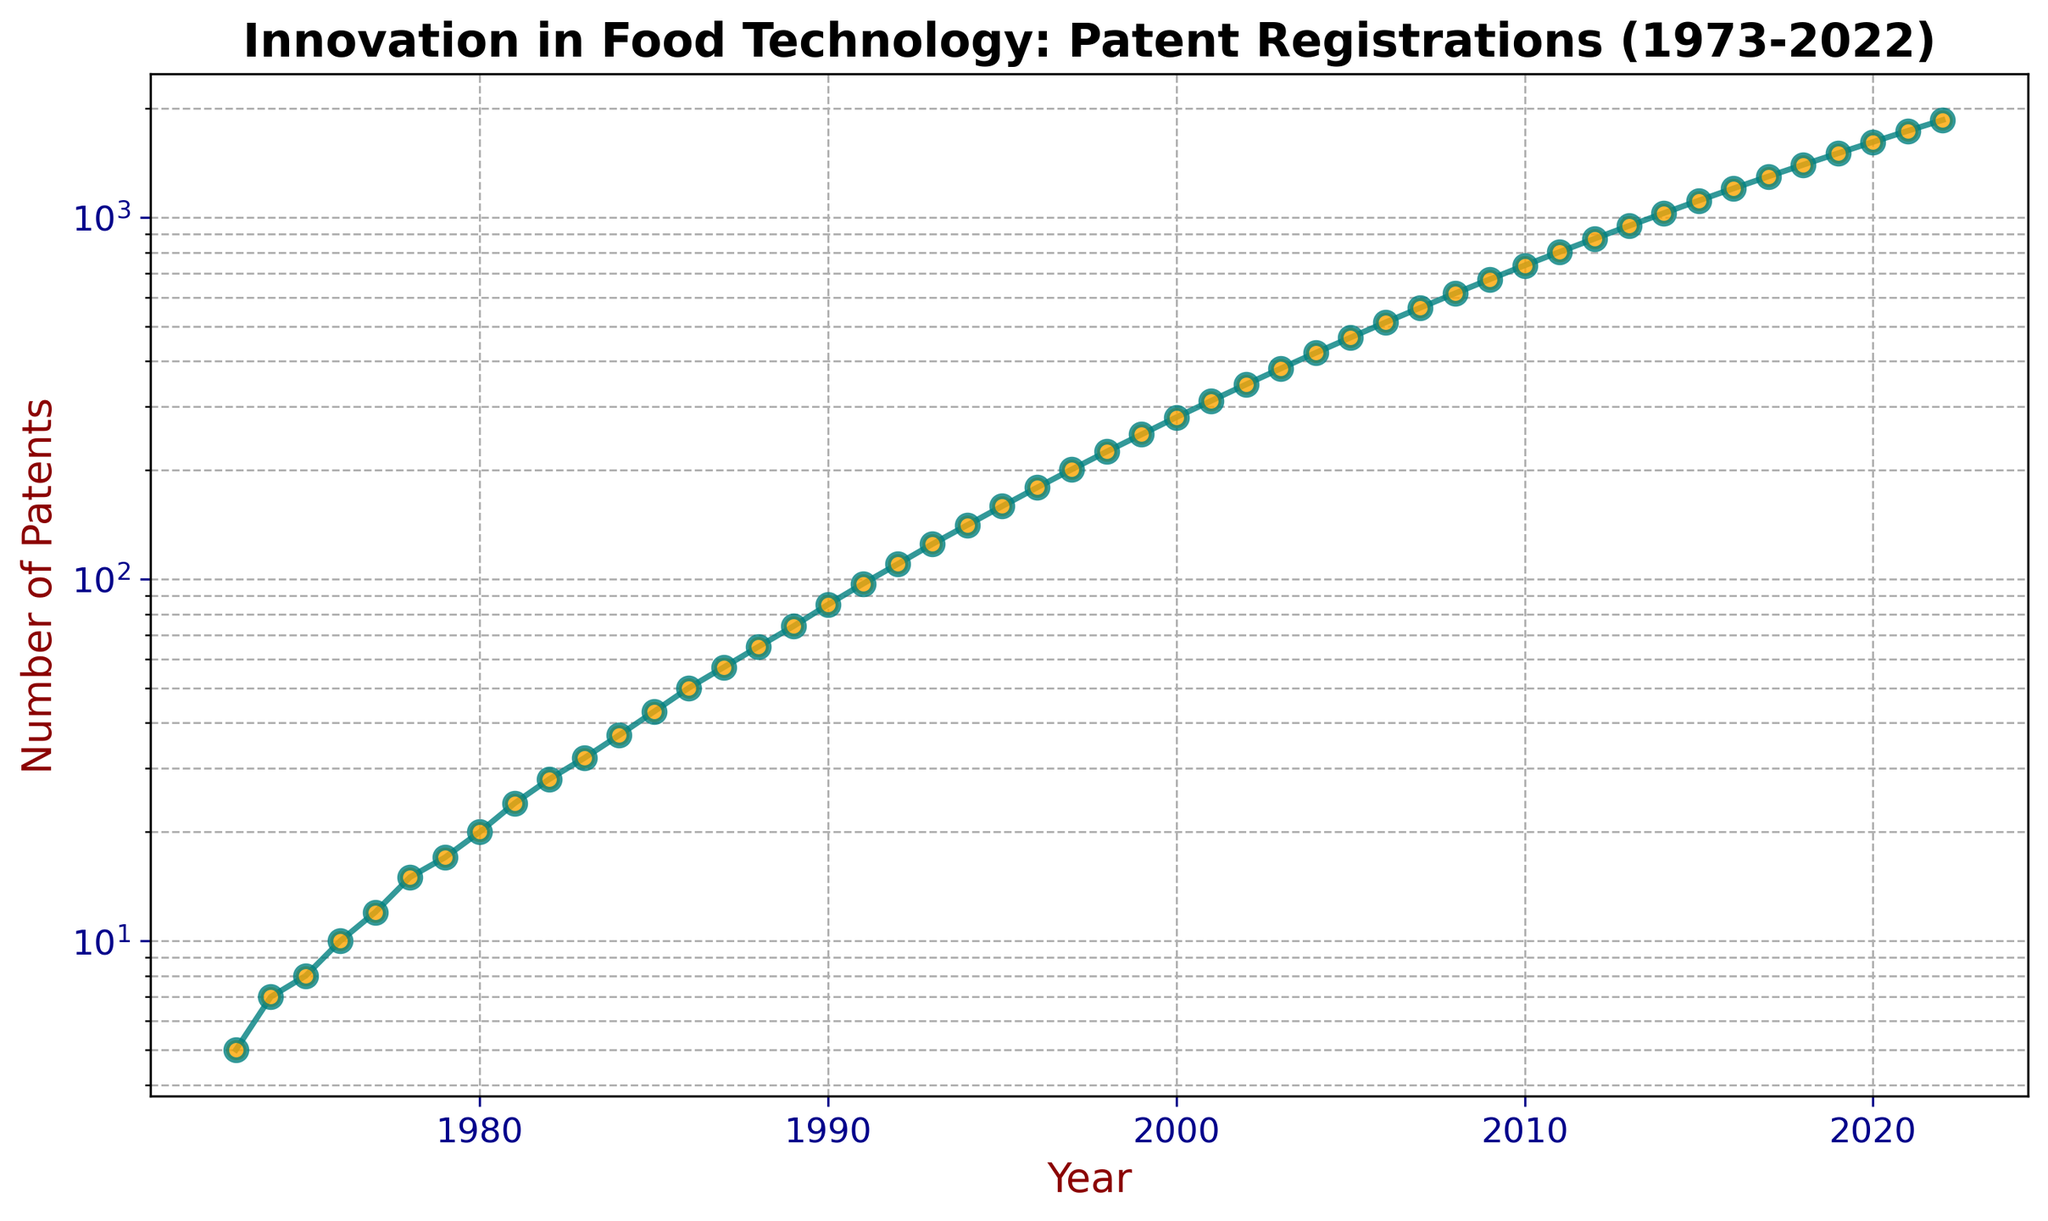What trend does the log-scaled axis reveal about the number of patents registered over the years? The log scale shows a steady and exponential increase in the number of patents over the years. This means the growth rate is not linear; it accelerates over time. On a log scale, a straight-line trend indicates exponential growth, which is what we observe.
Answer: Exponential growth In which decade did the patents increase from 10 to approximately 100? By observing the log-scaled plot, the increase from 10 to around 100 patents happens between 1976 and 1991. This period constitutes approximately 15 years, which spans the late 70s and 80s.
Answer: Late 70s to 80s What is the approximate number of patents registered in 2000, and how does it compare to 1989? In 2000, the number of patents is approximately 280. In 1989, it is around 74. Comparing these, we can see that the number of patents in 2000 is significantly higher than in 1989.
Answer: 280 in 2000 and 74 in 1989; 280 is significantly higher Which year shows the steepest increase in the number of patents after 2005? After 2005, the steepest increase in the number of patents appears to be around 2010, where the number of patents shows a significant upward trend. The jump between 2005 (465 patents) and 2010 (736 patents) is notable.
Answer: Around 2010 What is the percentage increase in the number of patents from 2015 to 2020? The number of patents in 2015 is approximately 1112, and in 2020, it is around 1615. The percentage increase can be calculated as ((1615 - 1112) / 1112) * 100. This calculation gives a percentage increase.
Answer: Approximately 45.2% Which decade showcases the most rapid growth in patent registrations? The most rapid growth is observed between 1992 and 2002, where the exponential trend on the log scale is more pronounced compared to other decades, indicating a higher rate of patent registrations growth.
Answer: 1990s During which periods do we see minor fluctuations in the upward trend of patents? Minor fluctuations can be observed around the late 2000s and early 2010s, where the line slightly wavers but generally continues its upward trend. This can be seen due to slight variations rather than a smooth curve.
Answer: Late 2000s and early 2010s In 2022, how many more patents are there compared to 1973? In 2022, there are 1857 patents, whereas in 1973, there were 5. The difference is 1857 - 5 = 1852 more patents in 2022 compared to 1973.
Answer: 1852 How does the rate of patent registration change before and after 1990? Before 1990, the growth is steady but slower. After 1990, the rate of patent registration increases more rapidly, as indicated by the steeper incline on the log-scaled graph. The exponential growth becomes more pronounced post-1990.
Answer: Faster after 1990 By how much did the number of patents increase from the year 2000 to 2010? In 2000, there are approximately 280 patents. In 2010, there are about 736. The increase is calculated by 736 - 280 = 456 patents.
Answer: 456 